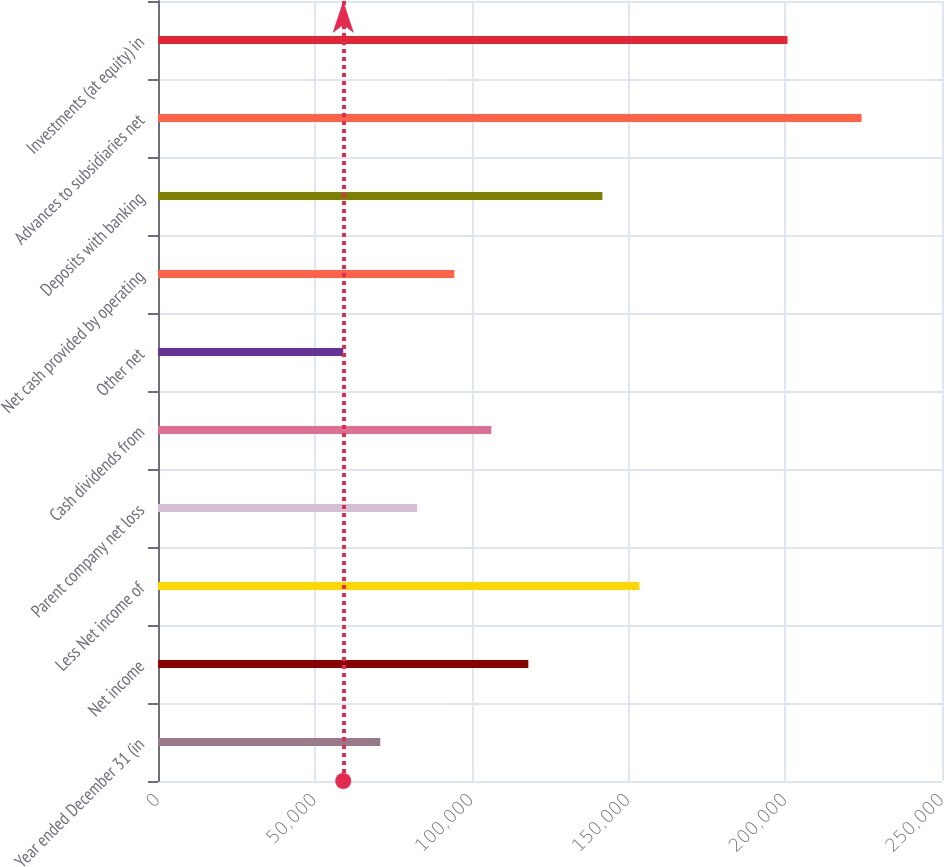Convert chart to OTSL. <chart><loc_0><loc_0><loc_500><loc_500><bar_chart><fcel>Year ended December 31 (in<fcel>Net income<fcel>Less Net income of<fcel>Parent company net loss<fcel>Cash dividends from<fcel>Other net<fcel>Net cash provided by operating<fcel>Deposits with banking<fcel>Advances to subsidiaries net<fcel>Investments (at equity) in<nl><fcel>70869.8<fcel>118093<fcel>153510<fcel>82675.6<fcel>106287<fcel>59064<fcel>94481.4<fcel>141705<fcel>224345<fcel>200734<nl></chart> 